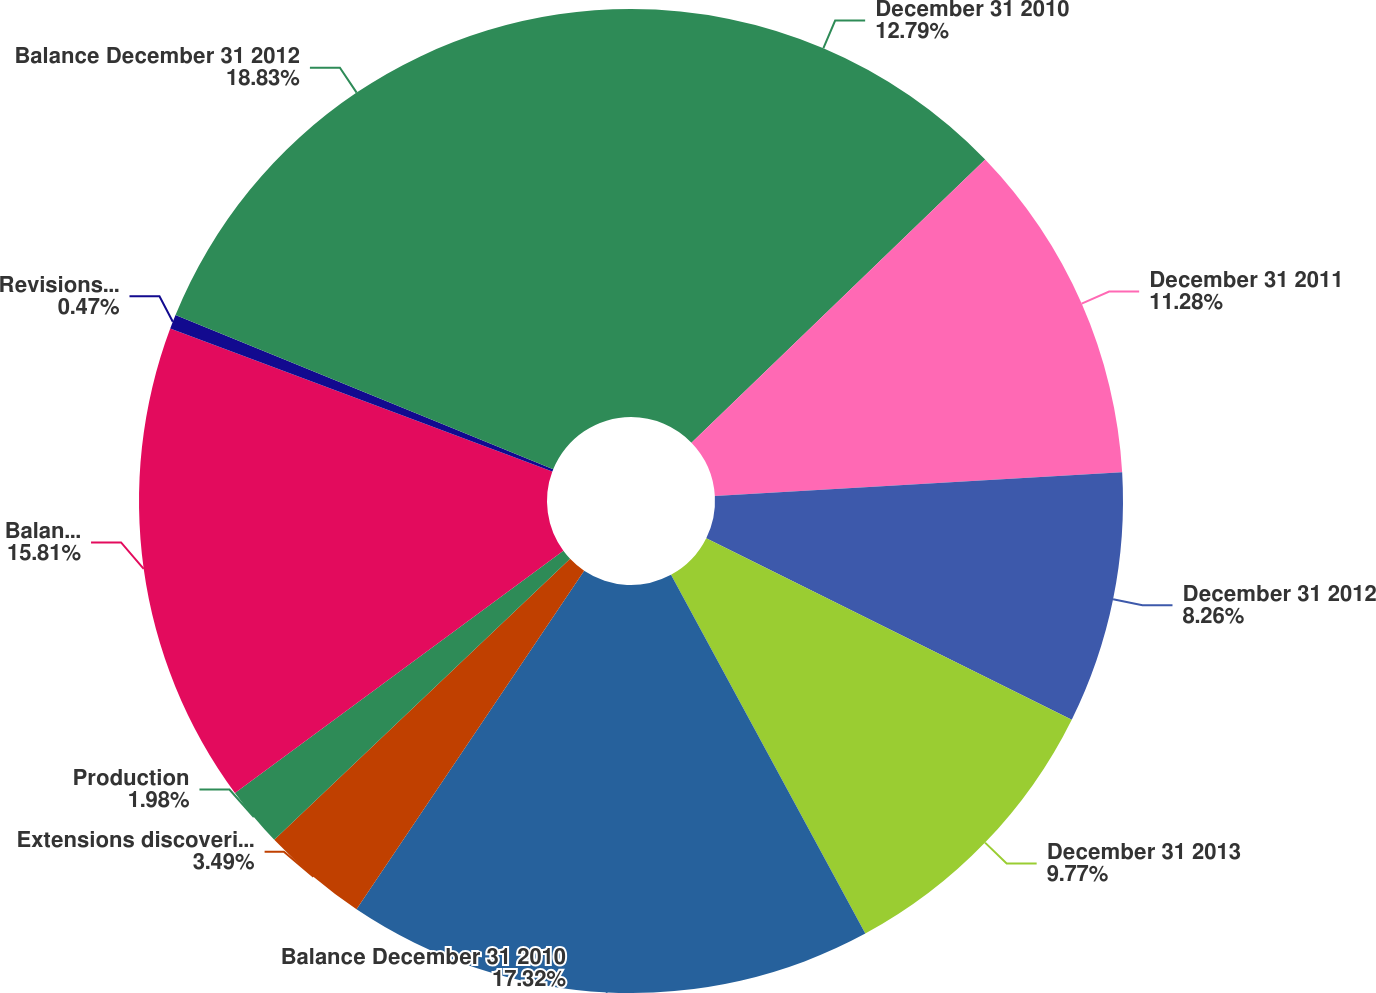Convert chart to OTSL. <chart><loc_0><loc_0><loc_500><loc_500><pie_chart><fcel>December 31 2010<fcel>December 31 2011<fcel>December 31 2012<fcel>December 31 2013<fcel>Balance December 31 2010<fcel>Extensions discoveries and<fcel>Production<fcel>Balance December 31 2011<fcel>Revisions of previous<fcel>Balance December 31 2012<nl><fcel>12.79%<fcel>11.28%<fcel>8.26%<fcel>9.77%<fcel>17.32%<fcel>3.49%<fcel>1.98%<fcel>15.81%<fcel>0.47%<fcel>18.83%<nl></chart> 